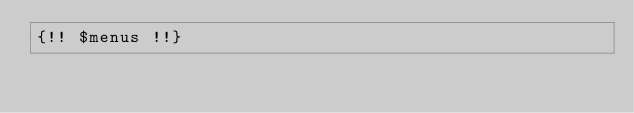<code> <loc_0><loc_0><loc_500><loc_500><_PHP_>{!! $menus !!}</code> 